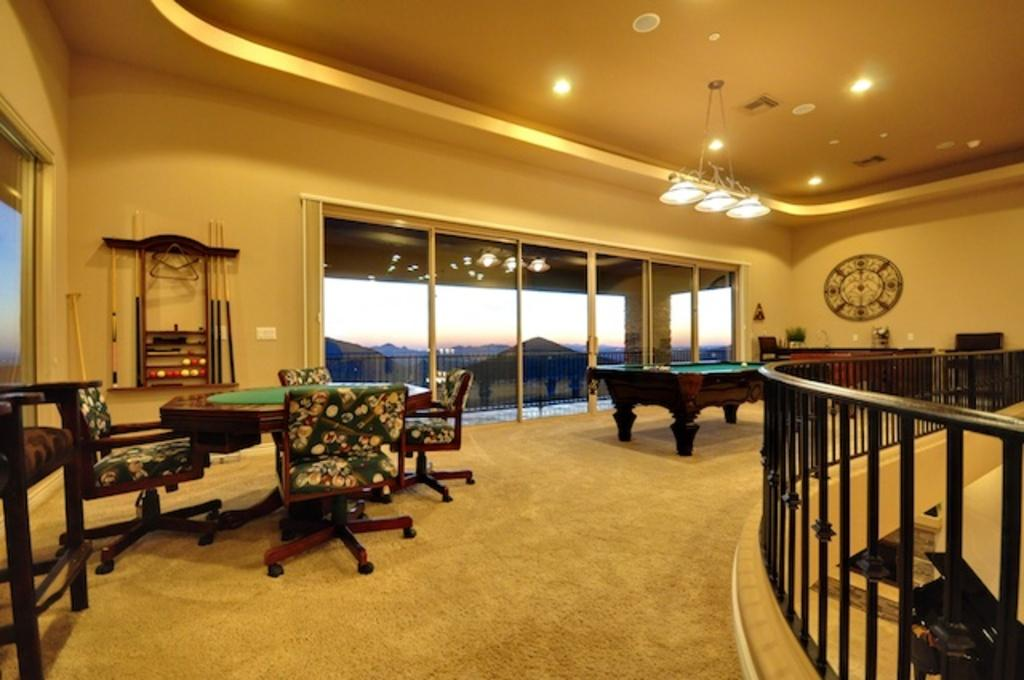What type of furniture is present in the room? There is a chair and a table in the room. What activity can be observed in the room? There is a billiard board in the room, with balls and sticks associated with it. What is the primary purpose of the sticks? The sticks are used to hit the balls on the billiard board. How many cribs are visible in the room? There are no cribs present in the room; the image features a billiard board and related equipment. What type of neck accessory is being worn by the balls on the billiard board? The balls on the billiard board do not have necks or any type of accessory; they are simply balls used for the game. 